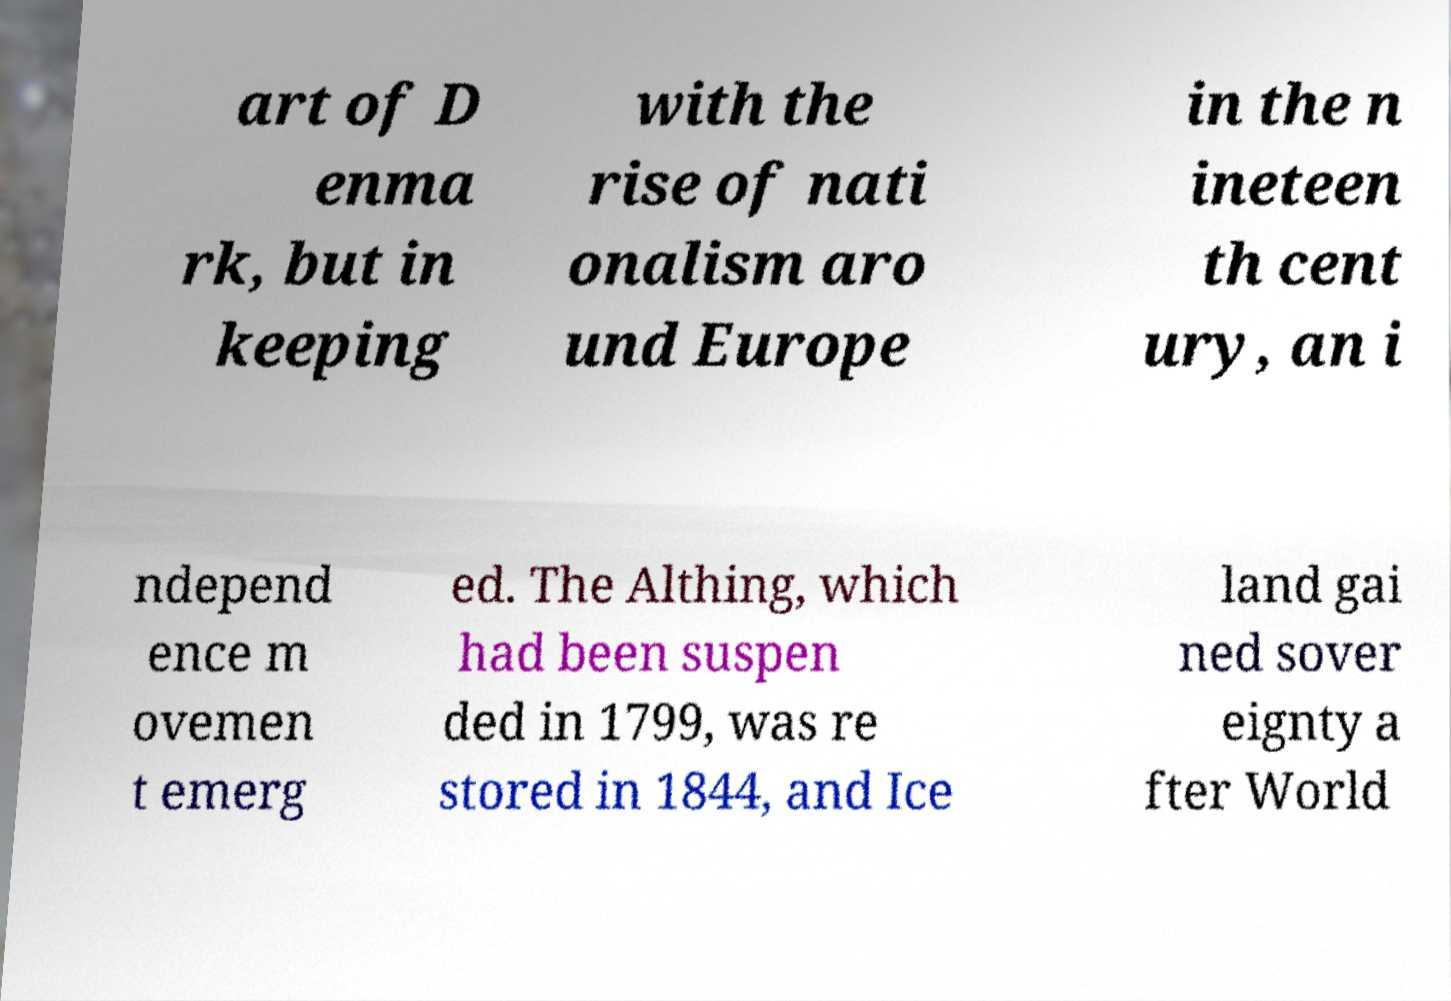Could you assist in decoding the text presented in this image and type it out clearly? art of D enma rk, but in keeping with the rise of nati onalism aro und Europe in the n ineteen th cent ury, an i ndepend ence m ovemen t emerg ed. The Althing, which had been suspen ded in 1799, was re stored in 1844, and Ice land gai ned sover eignty a fter World 